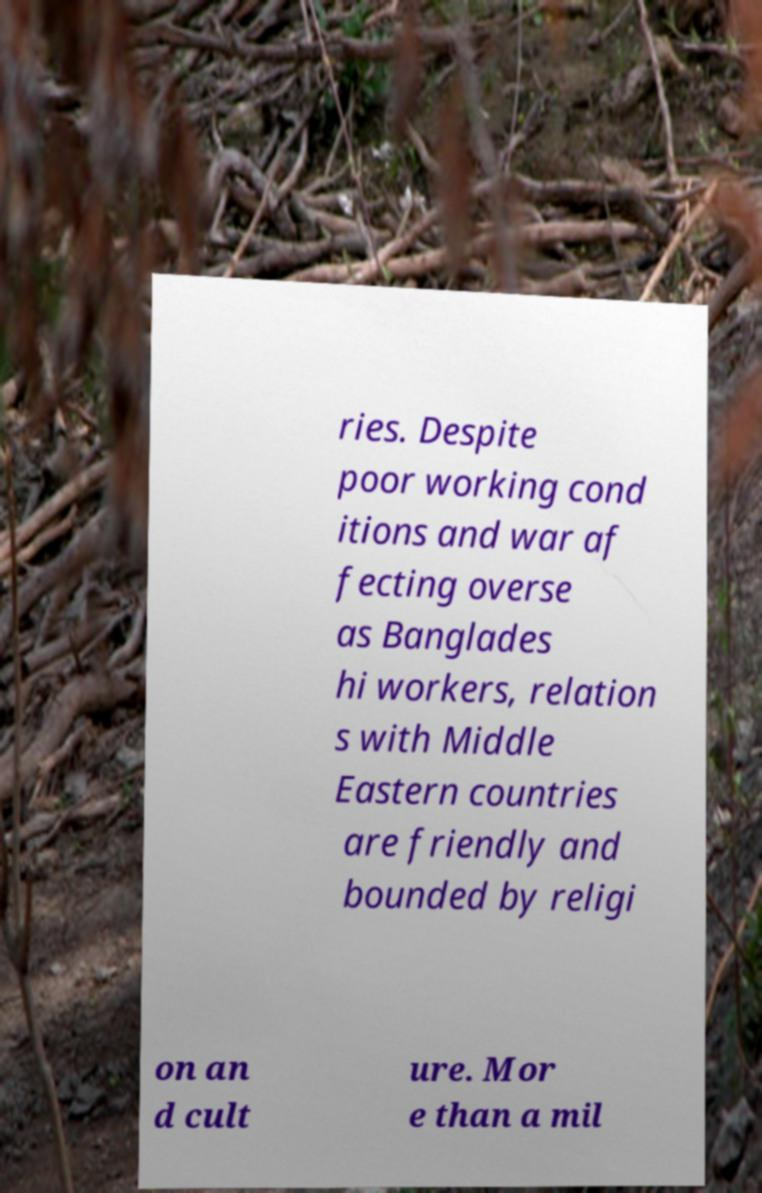For documentation purposes, I need the text within this image transcribed. Could you provide that? ries. Despite poor working cond itions and war af fecting overse as Banglades hi workers, relation s with Middle Eastern countries are friendly and bounded by religi on an d cult ure. Mor e than a mil 